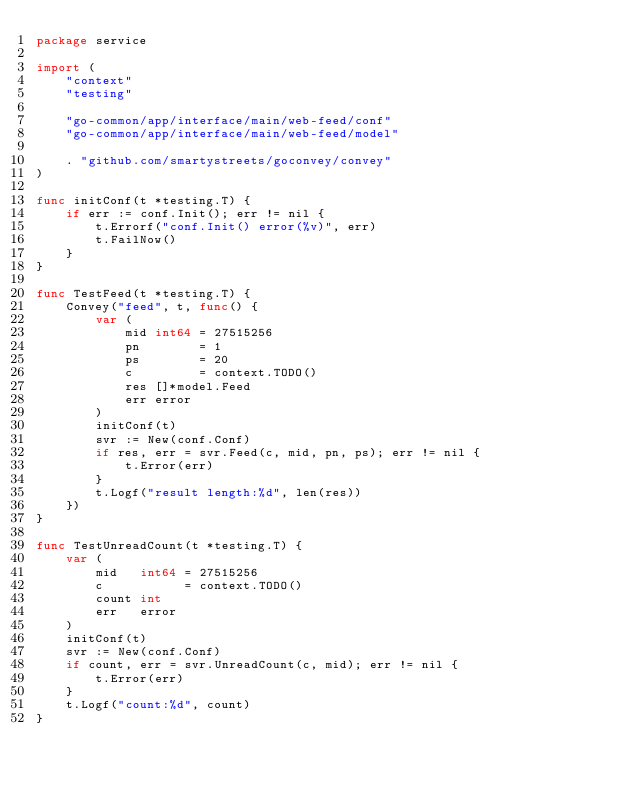Convert code to text. <code><loc_0><loc_0><loc_500><loc_500><_Go_>package service

import (
	"context"
	"testing"

	"go-common/app/interface/main/web-feed/conf"
	"go-common/app/interface/main/web-feed/model"

	. "github.com/smartystreets/goconvey/convey"
)

func initConf(t *testing.T) {
	if err := conf.Init(); err != nil {
		t.Errorf("conf.Init() error(%v)", err)
		t.FailNow()
	}
}

func TestFeed(t *testing.T) {
	Convey("feed", t, func() {
		var (
			mid int64 = 27515256
			pn        = 1
			ps        = 20
			c         = context.TODO()
			res []*model.Feed
			err error
		)
		initConf(t)
		svr := New(conf.Conf)
		if res, err = svr.Feed(c, mid, pn, ps); err != nil {
			t.Error(err)
		}
		t.Logf("result length:%d", len(res))
	})
}

func TestUnreadCount(t *testing.T) {
	var (
		mid   int64 = 27515256
		c           = context.TODO()
		count int
		err   error
	)
	initConf(t)
	svr := New(conf.Conf)
	if count, err = svr.UnreadCount(c, mid); err != nil {
		t.Error(err)
	}
	t.Logf("count:%d", count)
}
</code> 